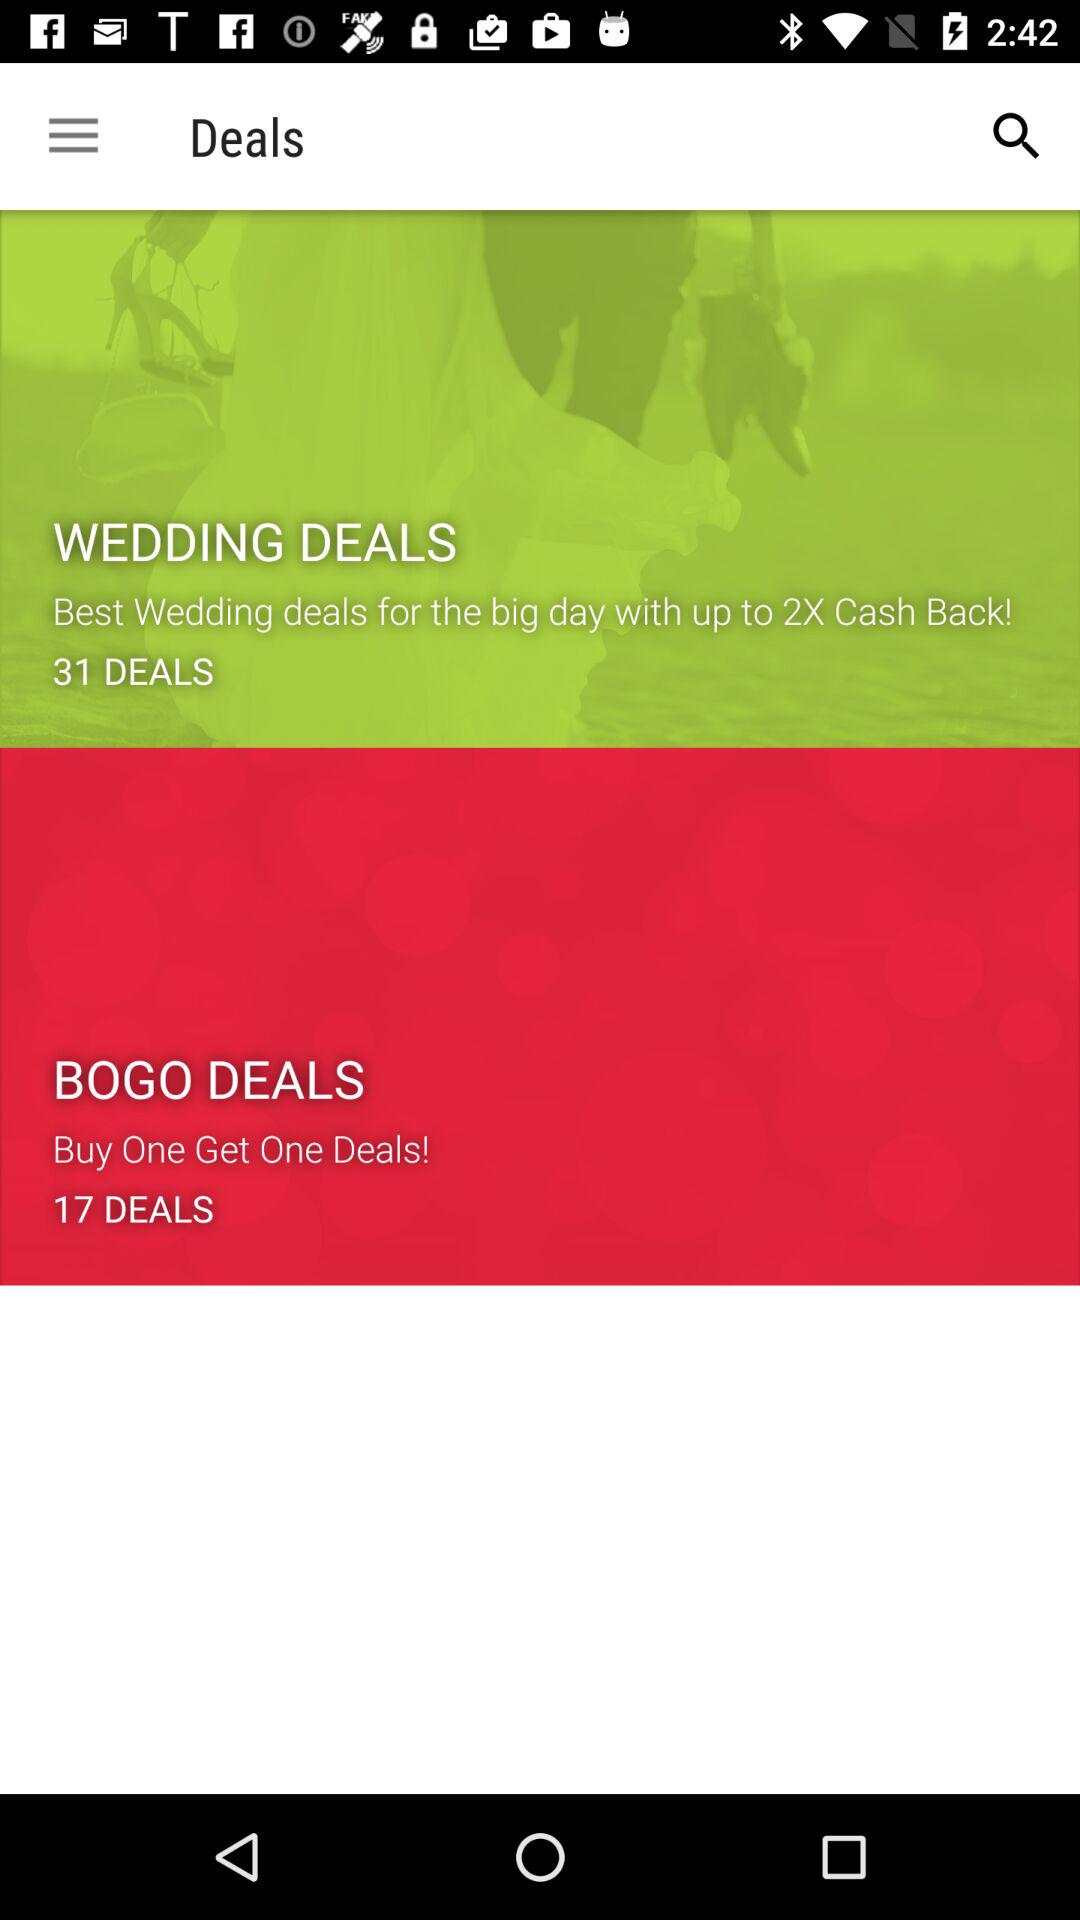How many wedding deals are there? There are 31 wedding deals. 